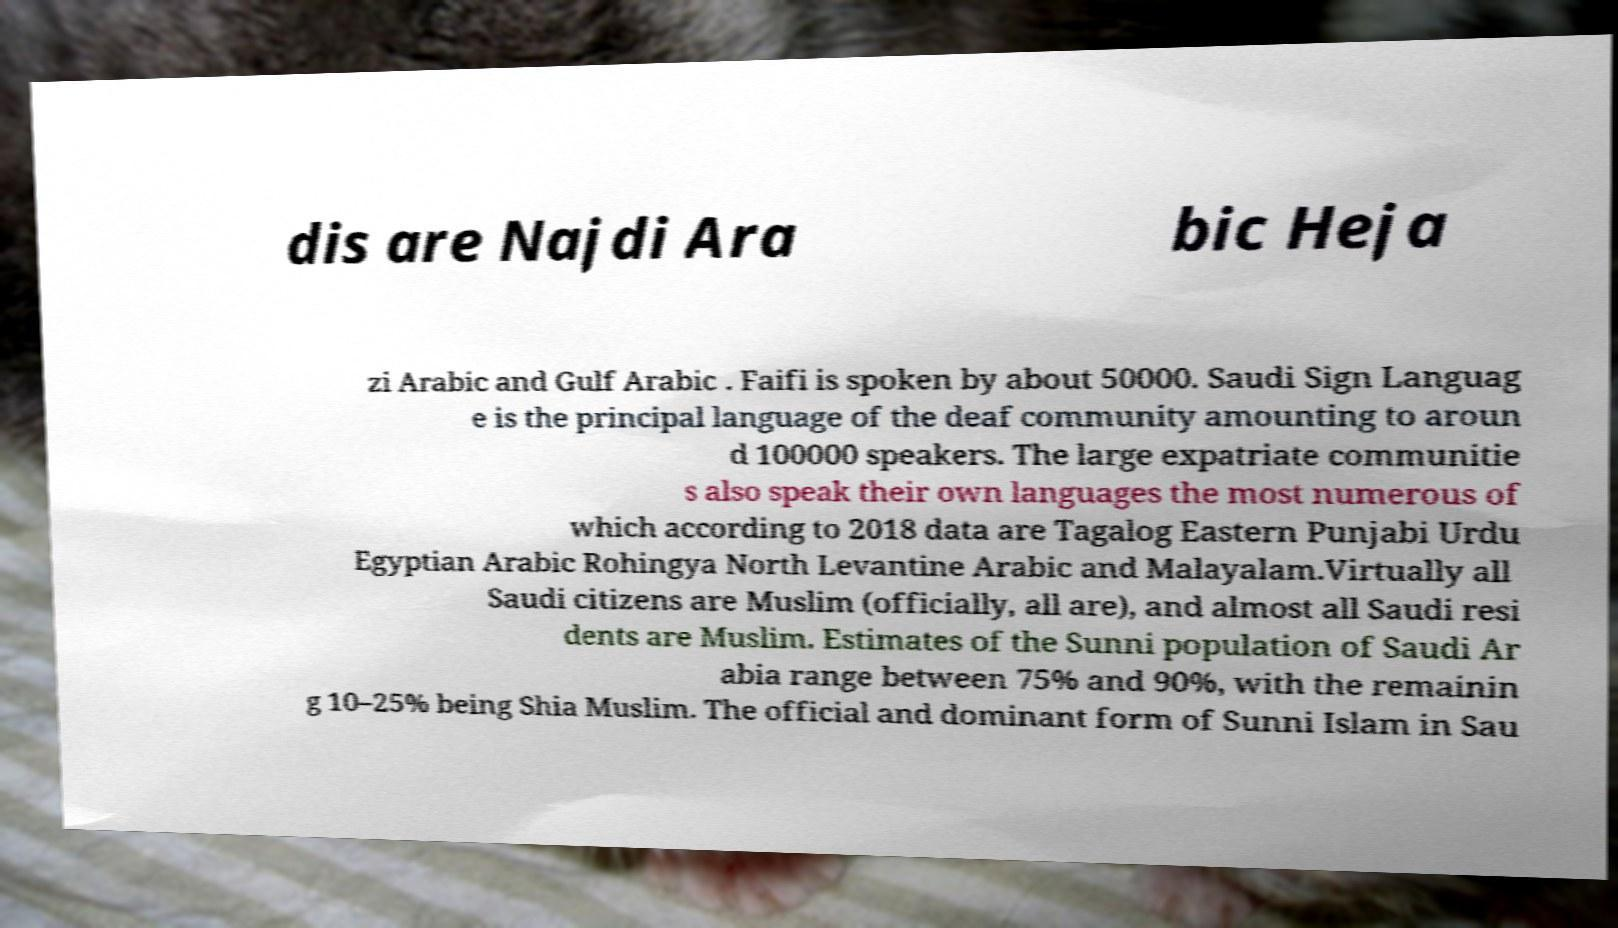For documentation purposes, I need the text within this image transcribed. Could you provide that? dis are Najdi Ara bic Heja zi Arabic and Gulf Arabic . Faifi is spoken by about 50000. Saudi Sign Languag e is the principal language of the deaf community amounting to aroun d 100000 speakers. The large expatriate communitie s also speak their own languages the most numerous of which according to 2018 data are Tagalog Eastern Punjabi Urdu Egyptian Arabic Rohingya North Levantine Arabic and Malayalam.Virtually all Saudi citizens are Muslim (officially, all are), and almost all Saudi resi dents are Muslim. Estimates of the Sunni population of Saudi Ar abia range between 75% and 90%, with the remainin g 10–25% being Shia Muslim. The official and dominant form of Sunni Islam in Sau 